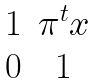Convert formula to latex. <formula><loc_0><loc_0><loc_500><loc_500>\begin{matrix} 1 & \pi ^ { t } x \\ 0 & 1 \end{matrix}</formula> 